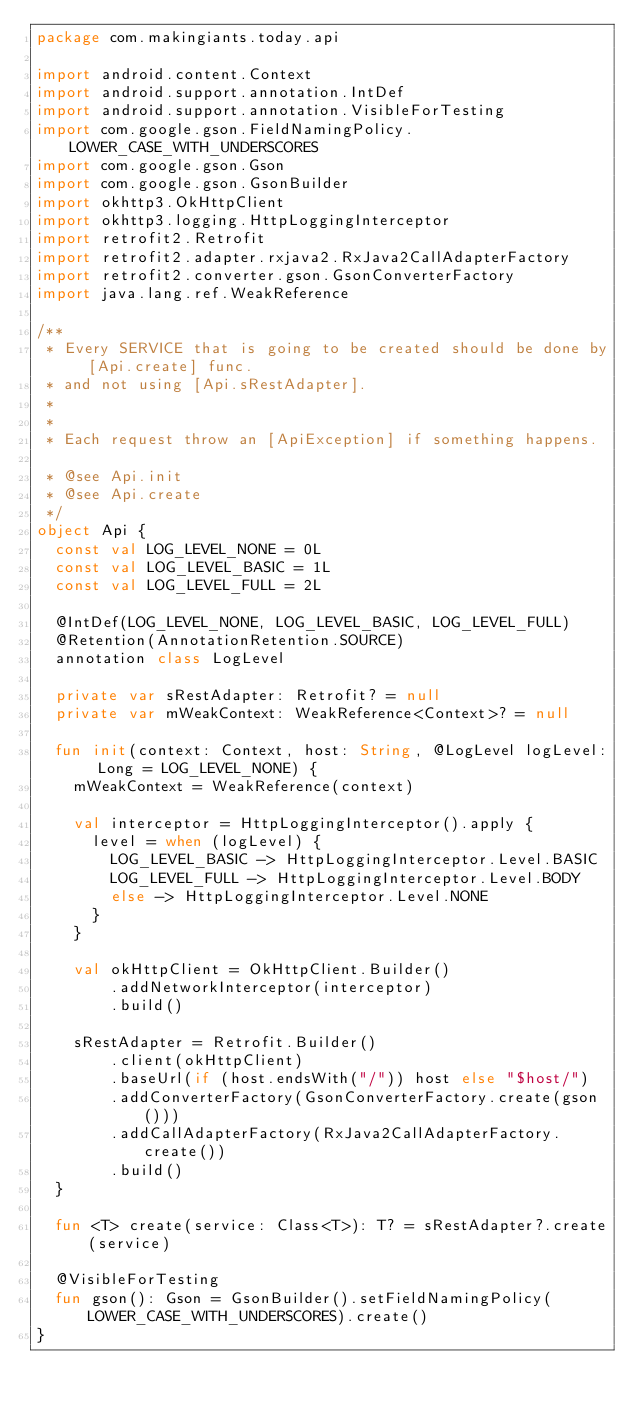<code> <loc_0><loc_0><loc_500><loc_500><_Kotlin_>package com.makingiants.today.api

import android.content.Context
import android.support.annotation.IntDef
import android.support.annotation.VisibleForTesting
import com.google.gson.FieldNamingPolicy.LOWER_CASE_WITH_UNDERSCORES
import com.google.gson.Gson
import com.google.gson.GsonBuilder
import okhttp3.OkHttpClient
import okhttp3.logging.HttpLoggingInterceptor
import retrofit2.Retrofit
import retrofit2.adapter.rxjava2.RxJava2CallAdapterFactory
import retrofit2.converter.gson.GsonConverterFactory
import java.lang.ref.WeakReference

/**
 * Every SERVICE that is going to be created should be done by [Api.create] func.
 * and not using [Api.sRestAdapter].
 *
 *
 * Each request throw an [ApiException] if something happens.

 * @see Api.init
 * @see Api.create
 */
object Api {
  const val LOG_LEVEL_NONE = 0L
  const val LOG_LEVEL_BASIC = 1L
  const val LOG_LEVEL_FULL = 2L

  @IntDef(LOG_LEVEL_NONE, LOG_LEVEL_BASIC, LOG_LEVEL_FULL)
  @Retention(AnnotationRetention.SOURCE)
  annotation class LogLevel

  private var sRestAdapter: Retrofit? = null
  private var mWeakContext: WeakReference<Context>? = null

  fun init(context: Context, host: String, @LogLevel logLevel: Long = LOG_LEVEL_NONE) {
    mWeakContext = WeakReference(context)

    val interceptor = HttpLoggingInterceptor().apply {
      level = when (logLevel) {
        LOG_LEVEL_BASIC -> HttpLoggingInterceptor.Level.BASIC
        LOG_LEVEL_FULL -> HttpLoggingInterceptor.Level.BODY
        else -> HttpLoggingInterceptor.Level.NONE
      }
    }

    val okHttpClient = OkHttpClient.Builder()
        .addNetworkInterceptor(interceptor)
        .build()

    sRestAdapter = Retrofit.Builder()
        .client(okHttpClient)
        .baseUrl(if (host.endsWith("/")) host else "$host/")
        .addConverterFactory(GsonConverterFactory.create(gson()))
        .addCallAdapterFactory(RxJava2CallAdapterFactory.create())
        .build()
  }

  fun <T> create(service: Class<T>): T? = sRestAdapter?.create(service)

  @VisibleForTesting
  fun gson(): Gson = GsonBuilder().setFieldNamingPolicy(LOWER_CASE_WITH_UNDERSCORES).create()
}
</code> 